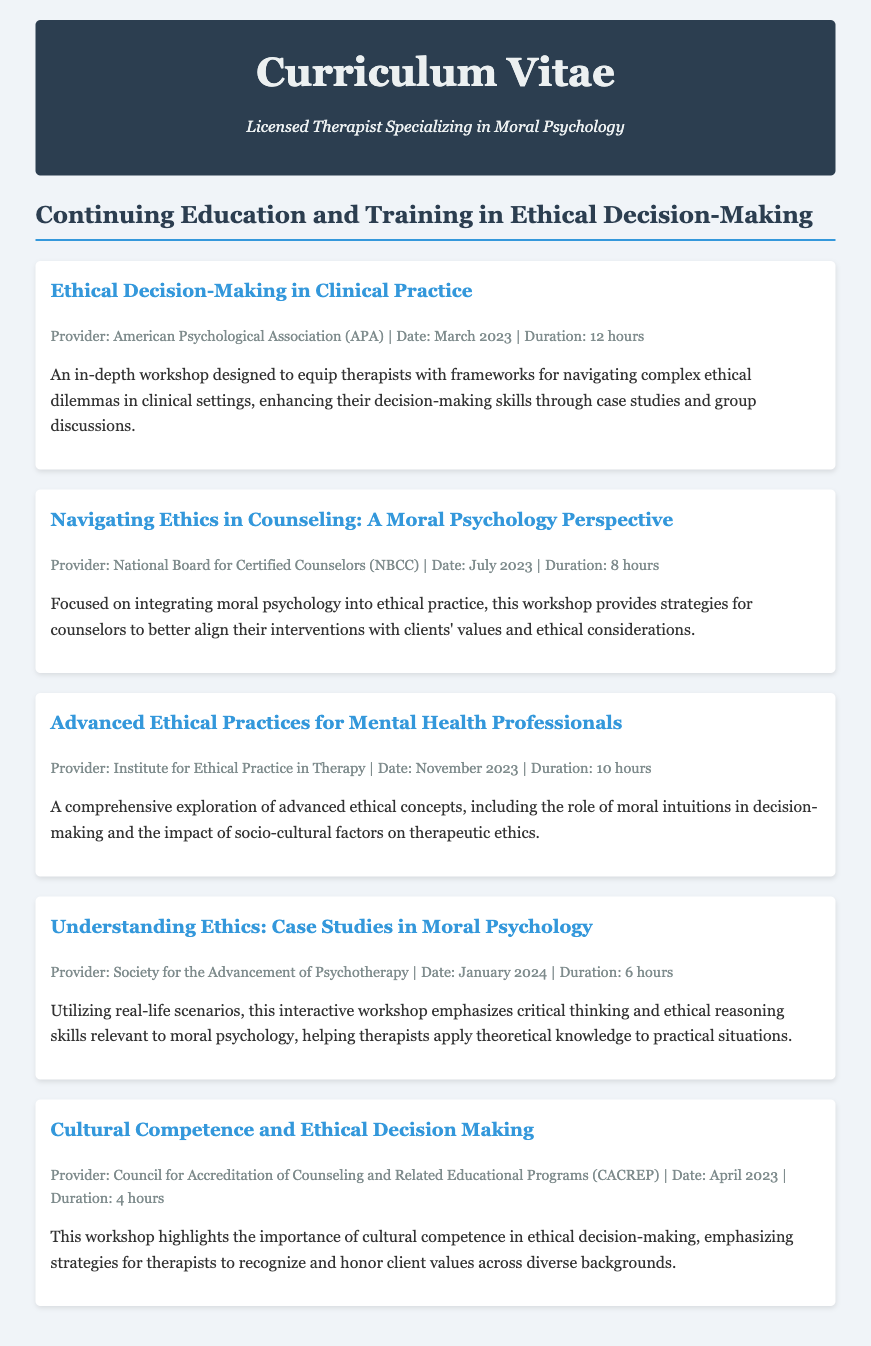What is the title of the first workshop listed? The first workshop listed in the document is titled "Ethical Decision-Making in Clinical Practice."
Answer: Ethical Decision-Making in Clinical Practice Who is the provider of the workshop on Cultural Competence? The workshop on Cultural Competence is provided by the Council for Accreditation of Counseling and Related Educational Programs (CACREP).
Answer: Council for Accreditation of Counseling and Related Educational Programs (CACREP) How many hours is the workshop on Navigating Ethics in Counseling? The workshop on Navigating Ethics in Counseling is 8 hours long.
Answer: 8 hours What month and year did the Advanced Ethical Practices workshop take place? The Advanced Ethical Practices workshop took place in November 2023.
Answer: November 2023 Which workshop focuses on cultural competence? The workshop that focuses on cultural competence is titled "Cultural Competence and Ethical Decision Making."
Answer: Cultural Competence and Ethical Decision Making How many total hours of training are provided by the first two workshops? The first workshop provides 12 hours and the second provides 8 hours, totaling 20 hours.
Answer: 20 hours What concept does the workshop on Understanding Ethics emphasize? The workshop on Understanding Ethics emphasizes critical thinking and ethical reasoning skills.
Answer: Critical thinking and ethical reasoning skills What is the subtitle under the main title of the Curriculum Vitae? The subtitle under the main title is "Licensed Therapist Specializing in Moral Psychology."
Answer: Licensed Therapist Specializing in Moral Psychology Which workshop is aimed at integrating moral psychology into ethical practice? The workshop aimed at integrating moral psychology into ethical practice is "Navigating Ethics in Counseling: A Moral Psychology Perspective."
Answer: Navigating Ethics in Counseling: A Moral Psychology Perspective 